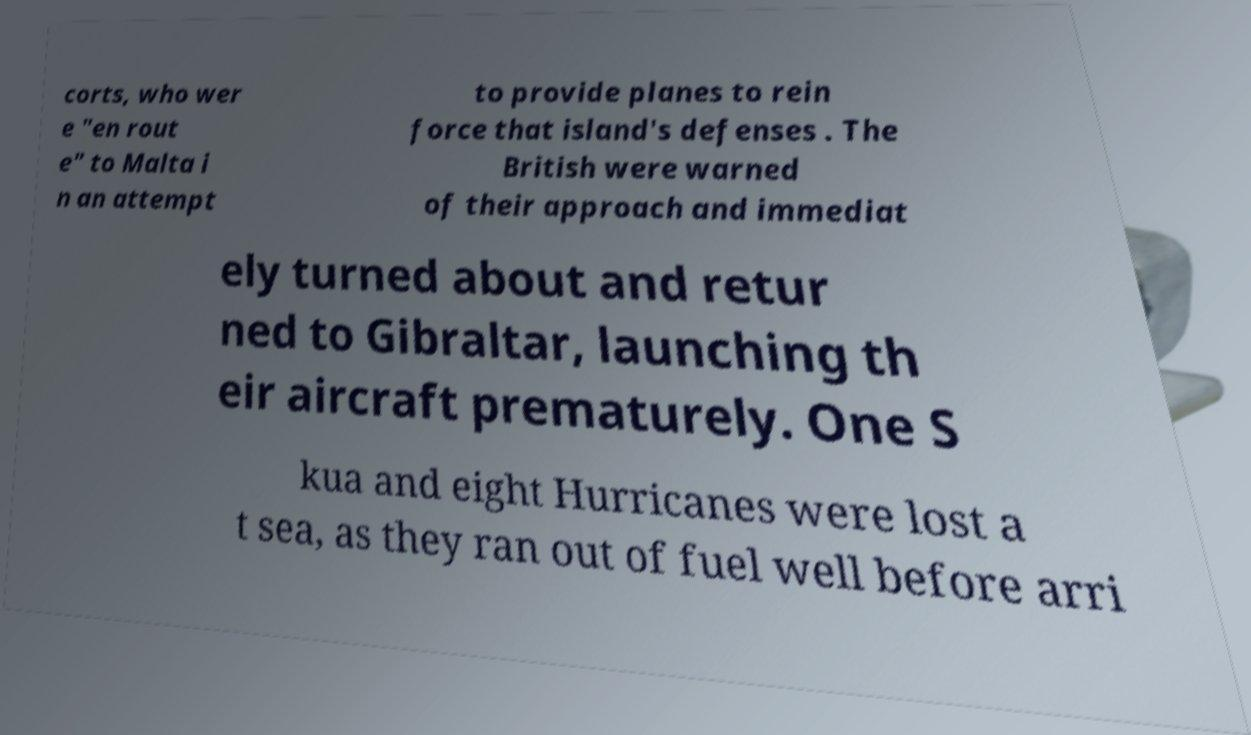Could you extract and type out the text from this image? corts, who wer e "en rout e" to Malta i n an attempt to provide planes to rein force that island's defenses . The British were warned of their approach and immediat ely turned about and retur ned to Gibraltar, launching th eir aircraft prematurely. One S kua and eight Hurricanes were lost a t sea, as they ran out of fuel well before arri 